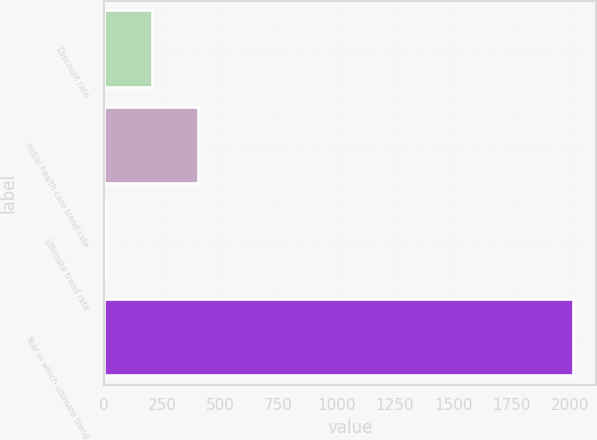Convert chart to OTSL. <chart><loc_0><loc_0><loc_500><loc_500><bar_chart><fcel>Discount rate<fcel>Initial health care trend rate<fcel>Ultimate trend rate<fcel>Year in which ultimate trend<nl><fcel>205.35<fcel>406.2<fcel>4.5<fcel>2013<nl></chart> 